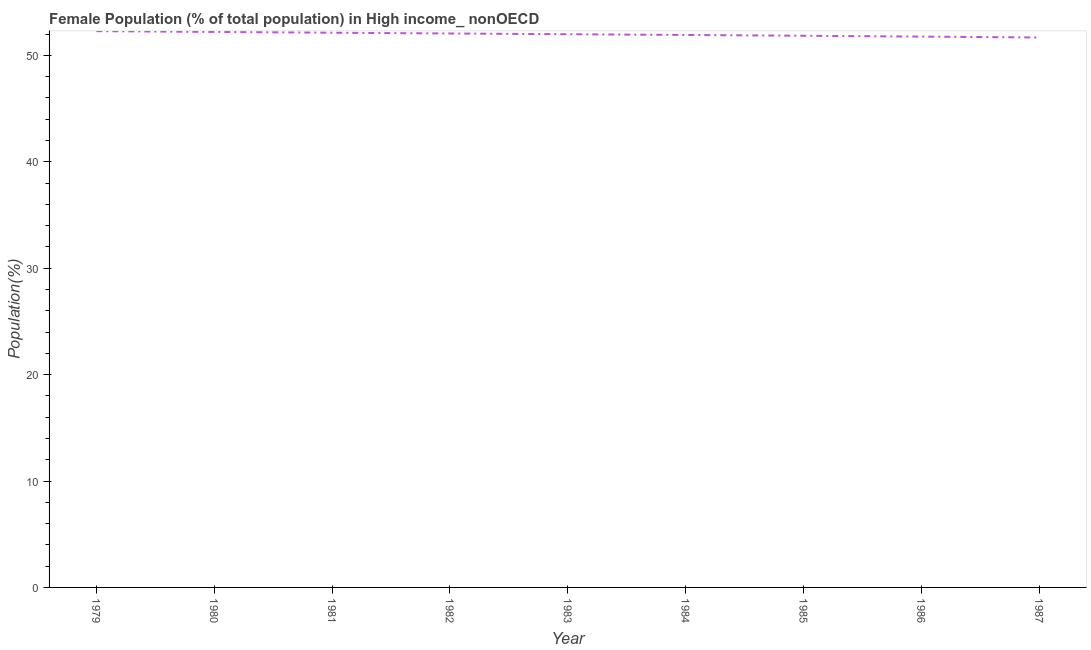What is the female population in 1982?
Keep it short and to the point. 52.05. Across all years, what is the maximum female population?
Offer a very short reply. 52.27. Across all years, what is the minimum female population?
Make the answer very short. 51.68. In which year was the female population maximum?
Give a very brief answer. 1979. In which year was the female population minimum?
Your answer should be very brief. 1987. What is the sum of the female population?
Keep it short and to the point. 467.8. What is the difference between the female population in 1981 and 1986?
Offer a terse response. 0.36. What is the average female population per year?
Provide a short and direct response. 51.98. What is the median female population?
Make the answer very short. 51.98. Do a majority of the years between 1985 and 1984 (inclusive) have female population greater than 38 %?
Ensure brevity in your answer.  No. What is the ratio of the female population in 1980 to that in 1984?
Your response must be concise. 1.01. Is the female population in 1981 less than that in 1987?
Ensure brevity in your answer.  No. What is the difference between the highest and the second highest female population?
Keep it short and to the point. 0.08. Is the sum of the female population in 1981 and 1985 greater than the maximum female population across all years?
Provide a succinct answer. Yes. What is the difference between the highest and the lowest female population?
Offer a terse response. 0.6. In how many years, is the female population greater than the average female population taken over all years?
Your answer should be compact. 5. How many lines are there?
Your response must be concise. 1. Are the values on the major ticks of Y-axis written in scientific E-notation?
Your answer should be very brief. No. Does the graph contain any zero values?
Keep it short and to the point. No. Does the graph contain grids?
Provide a succinct answer. No. What is the title of the graph?
Offer a terse response. Female Population (% of total population) in High income_ nonOECD. What is the label or title of the Y-axis?
Ensure brevity in your answer.  Population(%). What is the Population(%) in 1979?
Your answer should be compact. 52.27. What is the Population(%) of 1980?
Your answer should be very brief. 52.2. What is the Population(%) of 1981?
Ensure brevity in your answer.  52.12. What is the Population(%) in 1982?
Your answer should be compact. 52.05. What is the Population(%) of 1983?
Your answer should be very brief. 51.98. What is the Population(%) in 1984?
Keep it short and to the point. 51.91. What is the Population(%) of 1985?
Make the answer very short. 51.84. What is the Population(%) in 1986?
Provide a succinct answer. 51.76. What is the Population(%) of 1987?
Your answer should be compact. 51.68. What is the difference between the Population(%) in 1979 and 1980?
Offer a very short reply. 0.08. What is the difference between the Population(%) in 1979 and 1981?
Provide a short and direct response. 0.15. What is the difference between the Population(%) in 1979 and 1982?
Provide a short and direct response. 0.22. What is the difference between the Population(%) in 1979 and 1983?
Keep it short and to the point. 0.29. What is the difference between the Population(%) in 1979 and 1984?
Provide a succinct answer. 0.36. What is the difference between the Population(%) in 1979 and 1985?
Give a very brief answer. 0.43. What is the difference between the Population(%) in 1979 and 1986?
Your answer should be compact. 0.51. What is the difference between the Population(%) in 1979 and 1987?
Provide a short and direct response. 0.6. What is the difference between the Population(%) in 1980 and 1981?
Provide a short and direct response. 0.07. What is the difference between the Population(%) in 1980 and 1982?
Your answer should be very brief. 0.14. What is the difference between the Population(%) in 1980 and 1983?
Keep it short and to the point. 0.21. What is the difference between the Population(%) in 1980 and 1984?
Your answer should be compact. 0.28. What is the difference between the Population(%) in 1980 and 1985?
Ensure brevity in your answer.  0.36. What is the difference between the Population(%) in 1980 and 1986?
Keep it short and to the point. 0.44. What is the difference between the Population(%) in 1980 and 1987?
Make the answer very short. 0.52. What is the difference between the Population(%) in 1981 and 1982?
Offer a very short reply. 0.07. What is the difference between the Population(%) in 1981 and 1983?
Make the answer very short. 0.14. What is the difference between the Population(%) in 1981 and 1984?
Provide a short and direct response. 0.21. What is the difference between the Population(%) in 1981 and 1985?
Ensure brevity in your answer.  0.28. What is the difference between the Population(%) in 1981 and 1986?
Offer a terse response. 0.36. What is the difference between the Population(%) in 1981 and 1987?
Give a very brief answer. 0.45. What is the difference between the Population(%) in 1982 and 1983?
Make the answer very short. 0.07. What is the difference between the Population(%) in 1982 and 1984?
Give a very brief answer. 0.14. What is the difference between the Population(%) in 1982 and 1985?
Your answer should be very brief. 0.21. What is the difference between the Population(%) in 1982 and 1986?
Your response must be concise. 0.29. What is the difference between the Population(%) in 1982 and 1987?
Provide a short and direct response. 0.38. What is the difference between the Population(%) in 1983 and 1984?
Keep it short and to the point. 0.07. What is the difference between the Population(%) in 1983 and 1985?
Ensure brevity in your answer.  0.14. What is the difference between the Population(%) in 1983 and 1986?
Ensure brevity in your answer.  0.22. What is the difference between the Population(%) in 1983 and 1987?
Offer a terse response. 0.31. What is the difference between the Population(%) in 1984 and 1985?
Ensure brevity in your answer.  0.07. What is the difference between the Population(%) in 1984 and 1986?
Offer a very short reply. 0.15. What is the difference between the Population(%) in 1984 and 1987?
Offer a very short reply. 0.24. What is the difference between the Population(%) in 1985 and 1986?
Provide a short and direct response. 0.08. What is the difference between the Population(%) in 1985 and 1987?
Keep it short and to the point. 0.16. What is the difference between the Population(%) in 1986 and 1987?
Provide a succinct answer. 0.08. What is the ratio of the Population(%) in 1979 to that in 1980?
Provide a succinct answer. 1. What is the ratio of the Population(%) in 1979 to that in 1981?
Ensure brevity in your answer.  1. What is the ratio of the Population(%) in 1979 to that in 1982?
Your answer should be compact. 1. What is the ratio of the Population(%) in 1979 to that in 1983?
Provide a succinct answer. 1.01. What is the ratio of the Population(%) in 1979 to that in 1984?
Your answer should be very brief. 1.01. What is the ratio of the Population(%) in 1979 to that in 1985?
Make the answer very short. 1.01. What is the ratio of the Population(%) in 1979 to that in 1986?
Ensure brevity in your answer.  1.01. What is the ratio of the Population(%) in 1980 to that in 1981?
Provide a short and direct response. 1. What is the ratio of the Population(%) in 1980 to that in 1982?
Provide a succinct answer. 1. What is the ratio of the Population(%) in 1980 to that in 1984?
Ensure brevity in your answer.  1. What is the ratio of the Population(%) in 1980 to that in 1986?
Your answer should be very brief. 1.01. What is the ratio of the Population(%) in 1981 to that in 1983?
Provide a succinct answer. 1. What is the ratio of the Population(%) in 1981 to that in 1984?
Give a very brief answer. 1. What is the ratio of the Population(%) in 1982 to that in 1983?
Provide a short and direct response. 1. What is the ratio of the Population(%) in 1982 to that in 1986?
Keep it short and to the point. 1.01. What is the ratio of the Population(%) in 1982 to that in 1987?
Your answer should be very brief. 1.01. What is the ratio of the Population(%) in 1983 to that in 1984?
Your answer should be compact. 1. What is the ratio of the Population(%) in 1983 to that in 1986?
Offer a terse response. 1. What is the ratio of the Population(%) in 1984 to that in 1986?
Provide a short and direct response. 1. What is the ratio of the Population(%) in 1984 to that in 1987?
Ensure brevity in your answer.  1. 